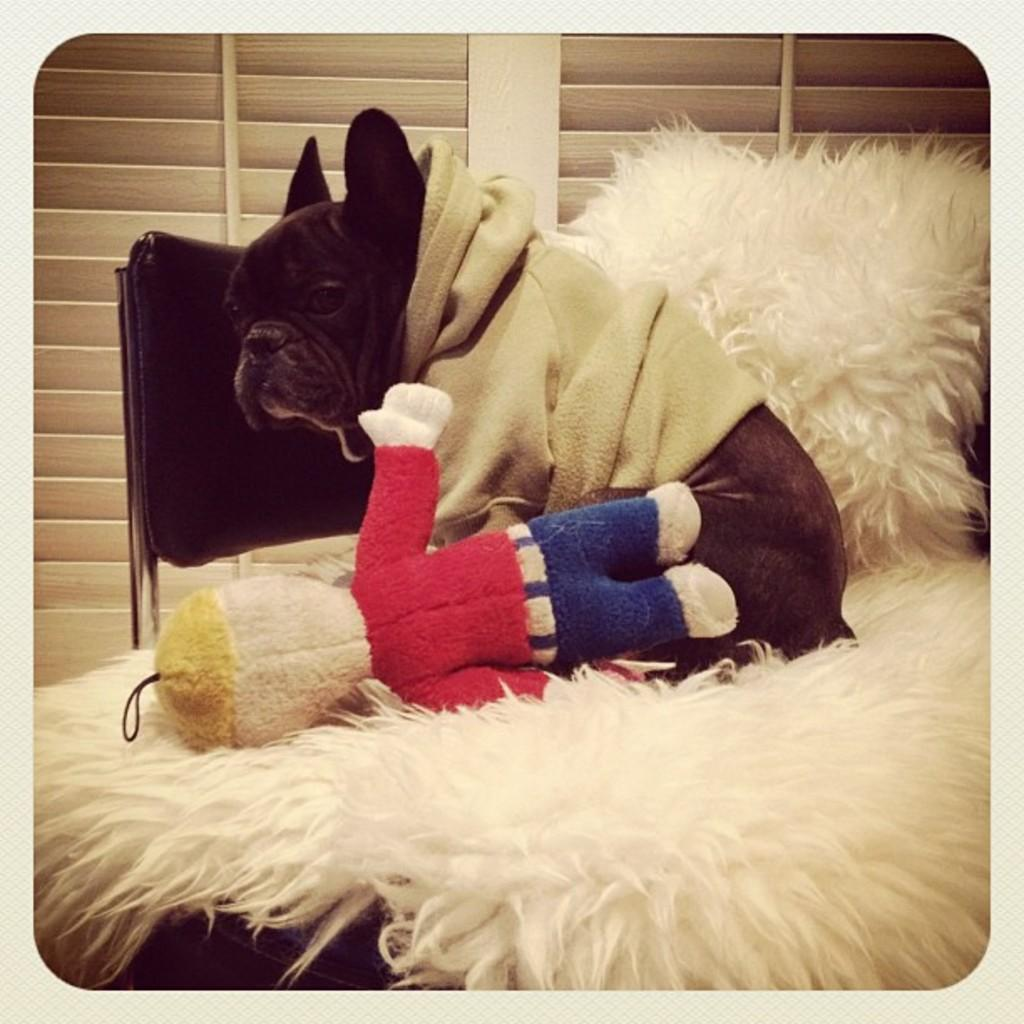What piece of furniture is in the image? There is a bed in the image. What is on the bed? There is a dog and a toy on the bed. What is used for support while sleeping on the bed? There is a pillow on the bed. What is beside the bed? There is a chair beside the bed. What can be seen in the background of the image? There is a curtain in the background of the image. How many spiders are crawling on the dog in the image? There are no spiders visible in the image; the dog is on the bed with a toy. What impulse might the dog have while lying on the bed? It is impossible to determine the dog's impulses from the image alone. 